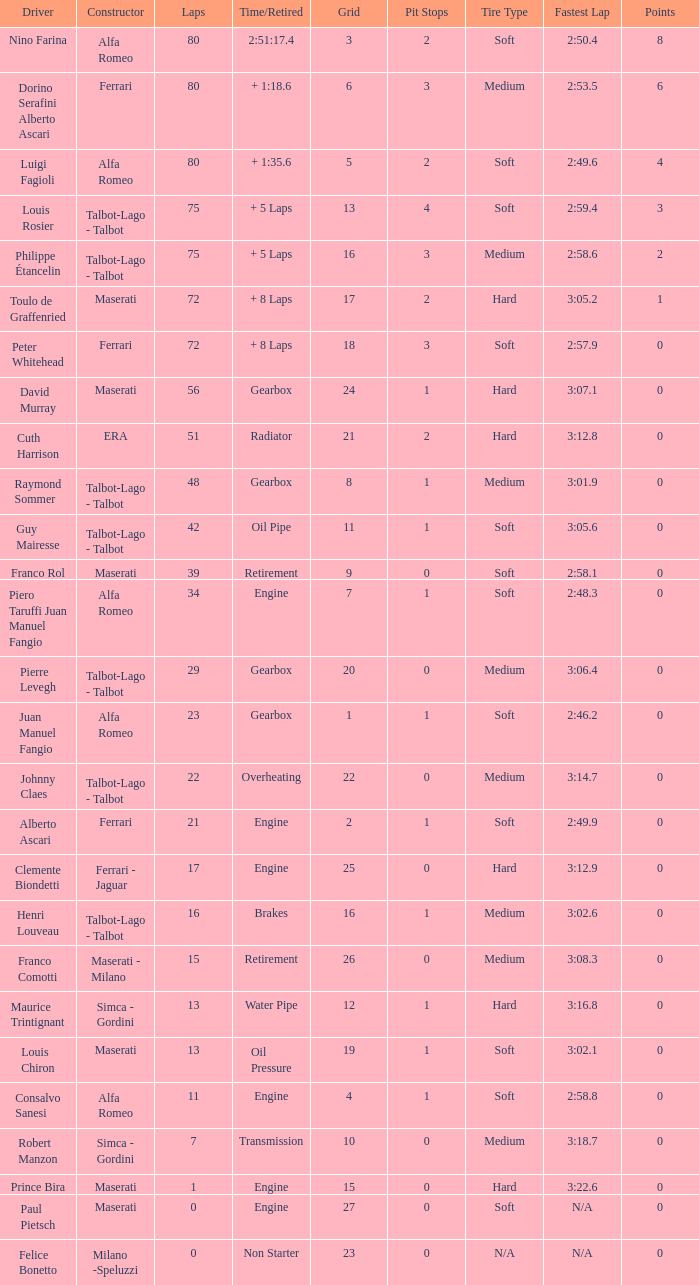When grid is less than 7, laps are greater than 17, and time/retired is + 1:35.6, who is the constructor? Alfa Romeo. 